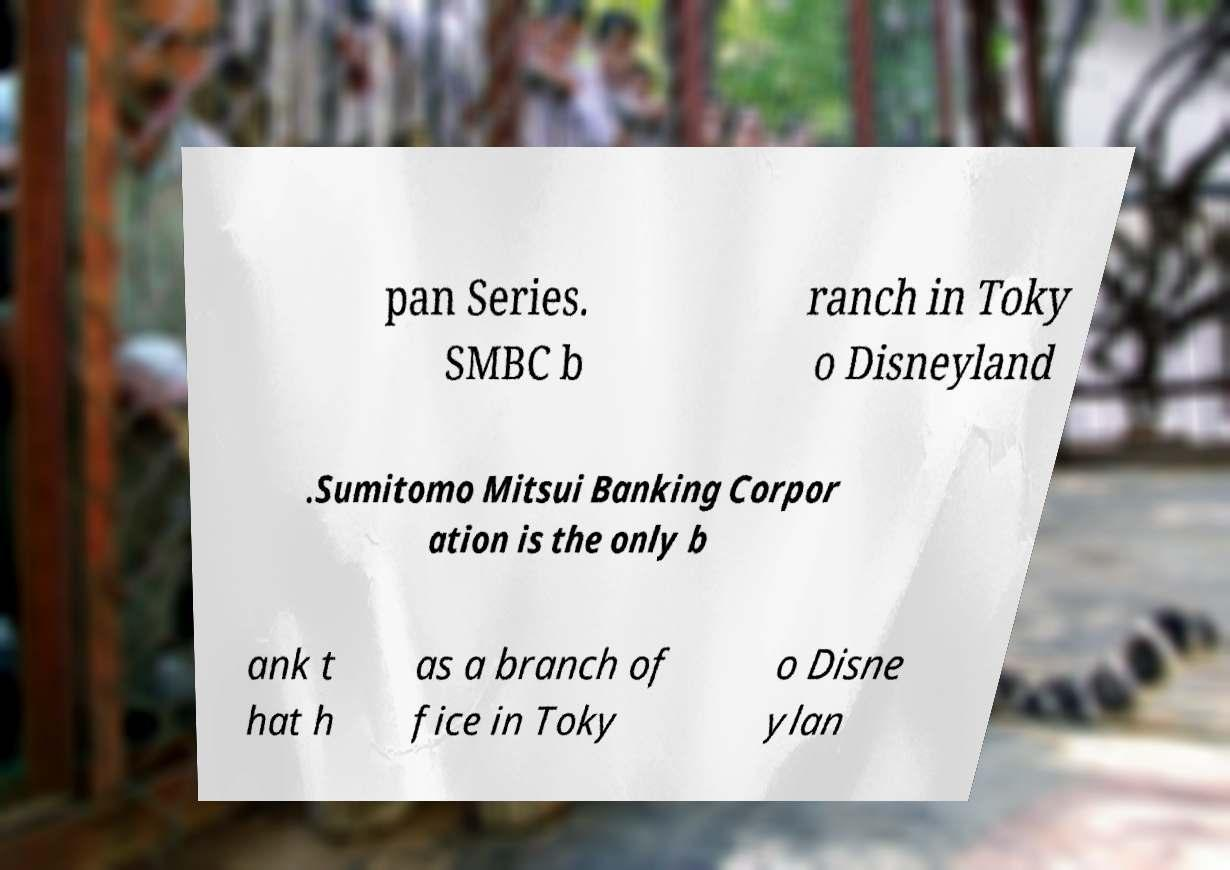What messages or text are displayed in this image? I need them in a readable, typed format. pan Series. SMBC b ranch in Toky o Disneyland .Sumitomo Mitsui Banking Corpor ation is the only b ank t hat h as a branch of fice in Toky o Disne ylan 